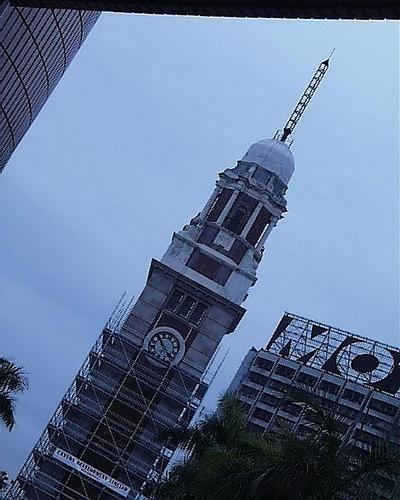How many letters can you see on the sign?
Give a very brief answer. 2. 